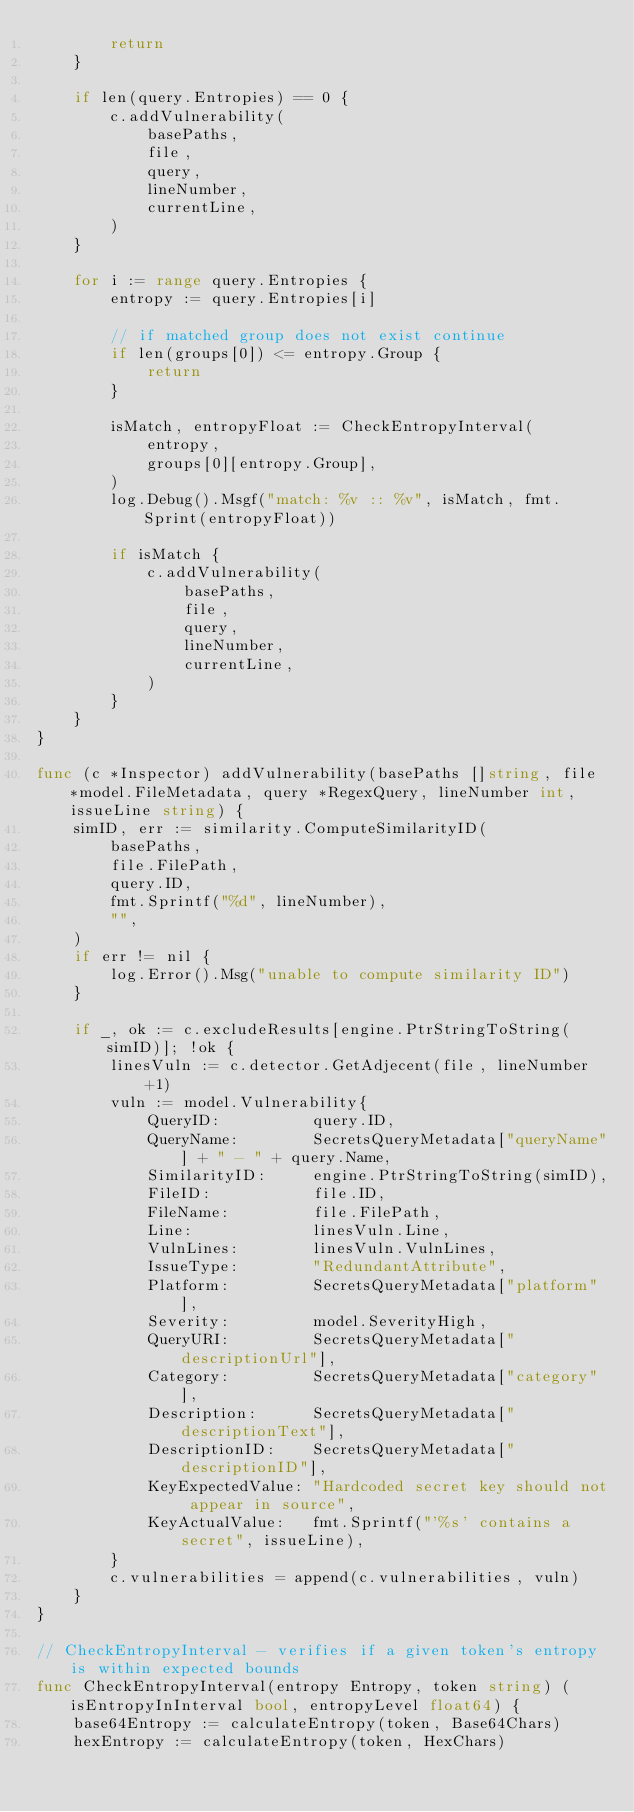<code> <loc_0><loc_0><loc_500><loc_500><_Go_>		return
	}

	if len(query.Entropies) == 0 {
		c.addVulnerability(
			basePaths,
			file,
			query,
			lineNumber,
			currentLine,
		)
	}

	for i := range query.Entropies {
		entropy := query.Entropies[i]

		// if matched group does not exist continue
		if len(groups[0]) <= entropy.Group {
			return
		}

		isMatch, entropyFloat := CheckEntropyInterval(
			entropy,
			groups[0][entropy.Group],
		)
		log.Debug().Msgf("match: %v :: %v", isMatch, fmt.Sprint(entropyFloat))

		if isMatch {
			c.addVulnerability(
				basePaths,
				file,
				query,
				lineNumber,
				currentLine,
			)
		}
	}
}

func (c *Inspector) addVulnerability(basePaths []string, file *model.FileMetadata, query *RegexQuery, lineNumber int, issueLine string) {
	simID, err := similarity.ComputeSimilarityID(
		basePaths,
		file.FilePath,
		query.ID,
		fmt.Sprintf("%d", lineNumber),
		"",
	)
	if err != nil {
		log.Error().Msg("unable to compute similarity ID")
	}

	if _, ok := c.excludeResults[engine.PtrStringToString(simID)]; !ok {
		linesVuln := c.detector.GetAdjecent(file, lineNumber+1)
		vuln := model.Vulnerability{
			QueryID:          query.ID,
			QueryName:        SecretsQueryMetadata["queryName"] + " - " + query.Name,
			SimilarityID:     engine.PtrStringToString(simID),
			FileID:           file.ID,
			FileName:         file.FilePath,
			Line:             linesVuln.Line,
			VulnLines:        linesVuln.VulnLines,
			IssueType:        "RedundantAttribute",
			Platform:         SecretsQueryMetadata["platform"],
			Severity:         model.SeverityHigh,
			QueryURI:         SecretsQueryMetadata["descriptionUrl"],
			Category:         SecretsQueryMetadata["category"],
			Description:      SecretsQueryMetadata["descriptionText"],
			DescriptionID:    SecretsQueryMetadata["descriptionID"],
			KeyExpectedValue: "Hardcoded secret key should not appear in source",
			KeyActualValue:   fmt.Sprintf("'%s' contains a secret", issueLine),
		}
		c.vulnerabilities = append(c.vulnerabilities, vuln)
	}
}

// CheckEntropyInterval - verifies if a given token's entropy is within expected bounds
func CheckEntropyInterval(entropy Entropy, token string) (isEntropyInInterval bool, entropyLevel float64) {
	base64Entropy := calculateEntropy(token, Base64Chars)
	hexEntropy := calculateEntropy(token, HexChars)</code> 